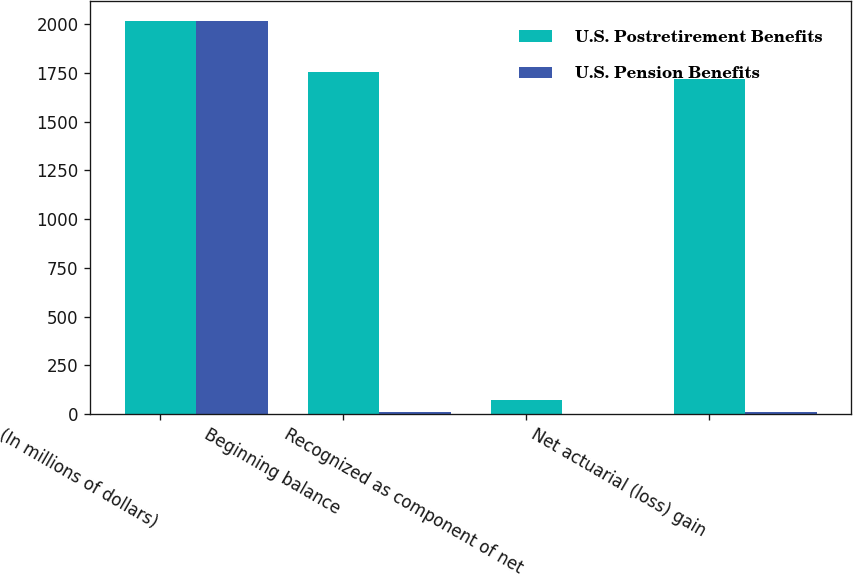Convert chart. <chart><loc_0><loc_0><loc_500><loc_500><stacked_bar_chart><ecel><fcel>(In millions of dollars)<fcel>Beginning balance<fcel>Recognized as component of net<fcel>Net actuarial (loss) gain<nl><fcel>U.S. Postretirement Benefits<fcel>2016<fcel>1754<fcel>74<fcel>1720<nl><fcel>U.S. Pension Benefits<fcel>2016<fcel>13<fcel>2<fcel>11<nl></chart> 